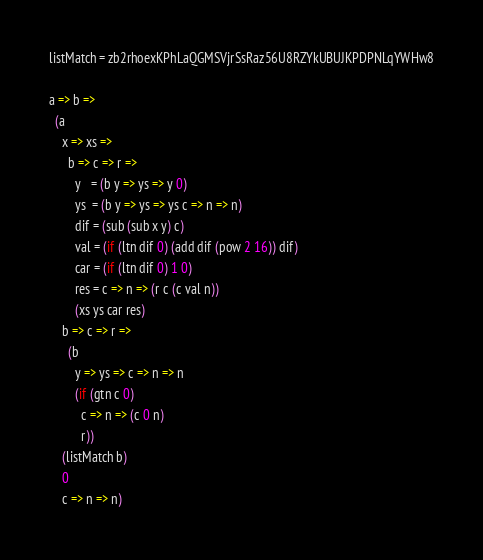<code> <loc_0><loc_0><loc_500><loc_500><_MoonScript_>listMatch = zb2rhoexKPhLaQGMSVjrSsRaz56U8RZYkUBUJKPDPNLqYWHw8

a => b =>
  (a
    x => xs =>
      b => c => r =>
        y   = (b y => ys => y 0)
        ys  = (b y => ys => ys c => n => n)
        dif = (sub (sub x y) c)
        val = (if (ltn dif 0) (add dif (pow 2 16)) dif)
        car = (if (ltn dif 0) 1 0)
        res = c => n => (r c (c val n))
        (xs ys car res)
    b => c => r =>
      (b
        y => ys => c => n => n
        (if (gtn c 0)
          c => n => (c 0 n)
          r))
    (listMatch b)
    0
    c => n => n)
</code> 